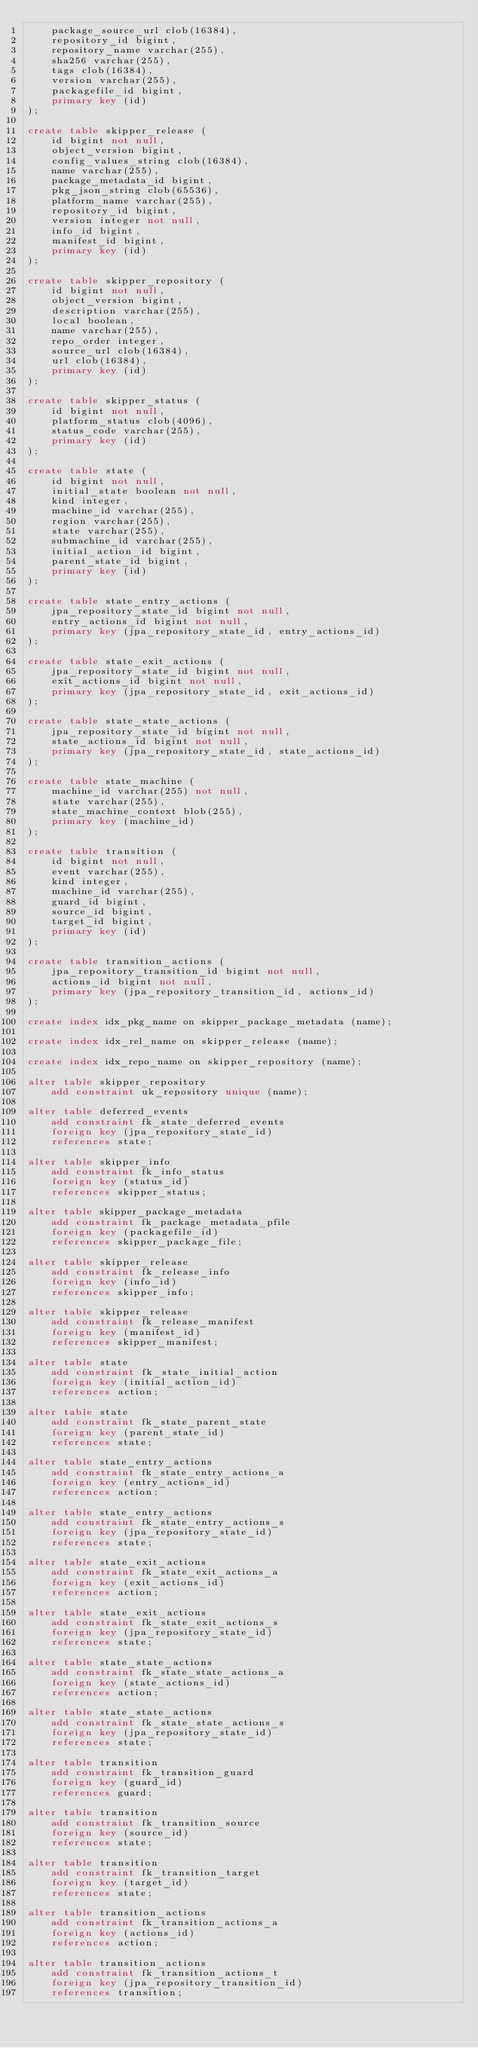Convert code to text. <code><loc_0><loc_0><loc_500><loc_500><_SQL_>    package_source_url clob(16384),
    repository_id bigint,
    repository_name varchar(255),
    sha256 varchar(255),
    tags clob(16384),
    version varchar(255),
    packagefile_id bigint,
    primary key (id)
);

create table skipper_release (
    id bigint not null,
    object_version bigint,
    config_values_string clob(16384),
    name varchar(255),
    package_metadata_id bigint,
    pkg_json_string clob(65536),
    platform_name varchar(255),
    repository_id bigint,
    version integer not null,
    info_id bigint,
    manifest_id bigint,
    primary key (id)
);

create table skipper_repository (
    id bigint not null,
    object_version bigint,
    description varchar(255),
    local boolean,
    name varchar(255),
    repo_order integer,
    source_url clob(16384),
    url clob(16384),
    primary key (id)
);

create table skipper_status (
    id bigint not null,
    platform_status clob(4096),
    status_code varchar(255),
    primary key (id)
);

create table state (
    id bigint not null,
    initial_state boolean not null,
    kind integer,
    machine_id varchar(255),
    region varchar(255),
    state varchar(255),
    submachine_id varchar(255),
    initial_action_id bigint,
    parent_state_id bigint,
    primary key (id)
);

create table state_entry_actions (
    jpa_repository_state_id bigint not null,
    entry_actions_id bigint not null,
    primary key (jpa_repository_state_id, entry_actions_id)
);

create table state_exit_actions (
    jpa_repository_state_id bigint not null,
    exit_actions_id bigint not null,
    primary key (jpa_repository_state_id, exit_actions_id)
);

create table state_state_actions (
    jpa_repository_state_id bigint not null,
    state_actions_id bigint not null,
    primary key (jpa_repository_state_id, state_actions_id)
);

create table state_machine (
    machine_id varchar(255) not null,
    state varchar(255),
    state_machine_context blob(255),
    primary key (machine_id)
);

create table transition (
    id bigint not null,
    event varchar(255),
    kind integer,
    machine_id varchar(255),
    guard_id bigint,
    source_id bigint,
    target_id bigint,
    primary key (id)
);

create table transition_actions (
    jpa_repository_transition_id bigint not null,
    actions_id bigint not null,
    primary key (jpa_repository_transition_id, actions_id)
);

create index idx_pkg_name on skipper_package_metadata (name);

create index idx_rel_name on skipper_release (name);

create index idx_repo_name on skipper_repository (name);

alter table skipper_repository
    add constraint uk_repository unique (name);

alter table deferred_events
    add constraint fk_state_deferred_events
    foreign key (jpa_repository_state_id)
    references state;

alter table skipper_info
    add constraint fk_info_status
    foreign key (status_id)
    references skipper_status;

alter table skipper_package_metadata
    add constraint fk_package_metadata_pfile
    foreign key (packagefile_id)
    references skipper_package_file;

alter table skipper_release
    add constraint fk_release_info
    foreign key (info_id)
    references skipper_info;

alter table skipper_release
    add constraint fk_release_manifest
    foreign key (manifest_id)
    references skipper_manifest;

alter table state
    add constraint fk_state_initial_action
    foreign key (initial_action_id)
    references action;

alter table state
    add constraint fk_state_parent_state
    foreign key (parent_state_id)
    references state;

alter table state_entry_actions
    add constraint fk_state_entry_actions_a
    foreign key (entry_actions_id)
    references action;

alter table state_entry_actions
    add constraint fk_state_entry_actions_s
    foreign key (jpa_repository_state_id)
    references state;

alter table state_exit_actions
    add constraint fk_state_exit_actions_a
    foreign key (exit_actions_id)
    references action;

alter table state_exit_actions
    add constraint fk_state_exit_actions_s
    foreign key (jpa_repository_state_id)
    references state;

alter table state_state_actions
    add constraint fk_state_state_actions_a
    foreign key (state_actions_id)
    references action;

alter table state_state_actions
    add constraint fk_state_state_actions_s
    foreign key (jpa_repository_state_id)
    references state;

alter table transition
    add constraint fk_transition_guard
    foreign key (guard_id)
    references guard;

alter table transition
    add constraint fk_transition_source
    foreign key (source_id)
    references state;

alter table transition
    add constraint fk_transition_target
    foreign key (target_id)
    references state;

alter table transition_actions
    add constraint fk_transition_actions_a
    foreign key (actions_id)
    references action;

alter table transition_actions
    add constraint fk_transition_actions_t
    foreign key (jpa_repository_transition_id)
    references transition;
</code> 